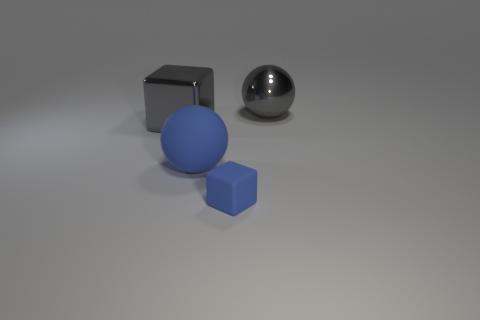How many other things are made of the same material as the large gray cube?
Make the answer very short. 1. Is the number of cyan matte cubes greater than the number of big gray metallic objects?
Your answer should be very brief. No. There is a large sphere that is left of the small blue rubber object; is it the same color as the small block?
Make the answer very short. Yes. What is the color of the big metal sphere?
Keep it short and to the point. Gray. Are there any gray objects that are behind the rubber thing that is on the right side of the blue ball?
Offer a very short reply. Yes. The big gray metallic object to the right of the large object in front of the large gray block is what shape?
Make the answer very short. Sphere. Are there fewer blue matte balls than large brown metallic spheres?
Give a very brief answer. No. Do the small block and the gray ball have the same material?
Offer a terse response. No. There is a thing that is to the right of the large blue rubber ball and behind the tiny matte block; what is its color?
Offer a terse response. Gray. Are there any shiny balls of the same size as the blue matte block?
Offer a very short reply. No. 